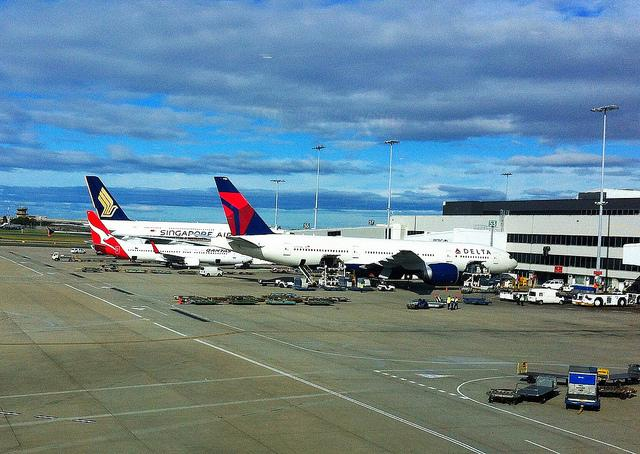How many different airlines are being featured by the planes in the photo? three 